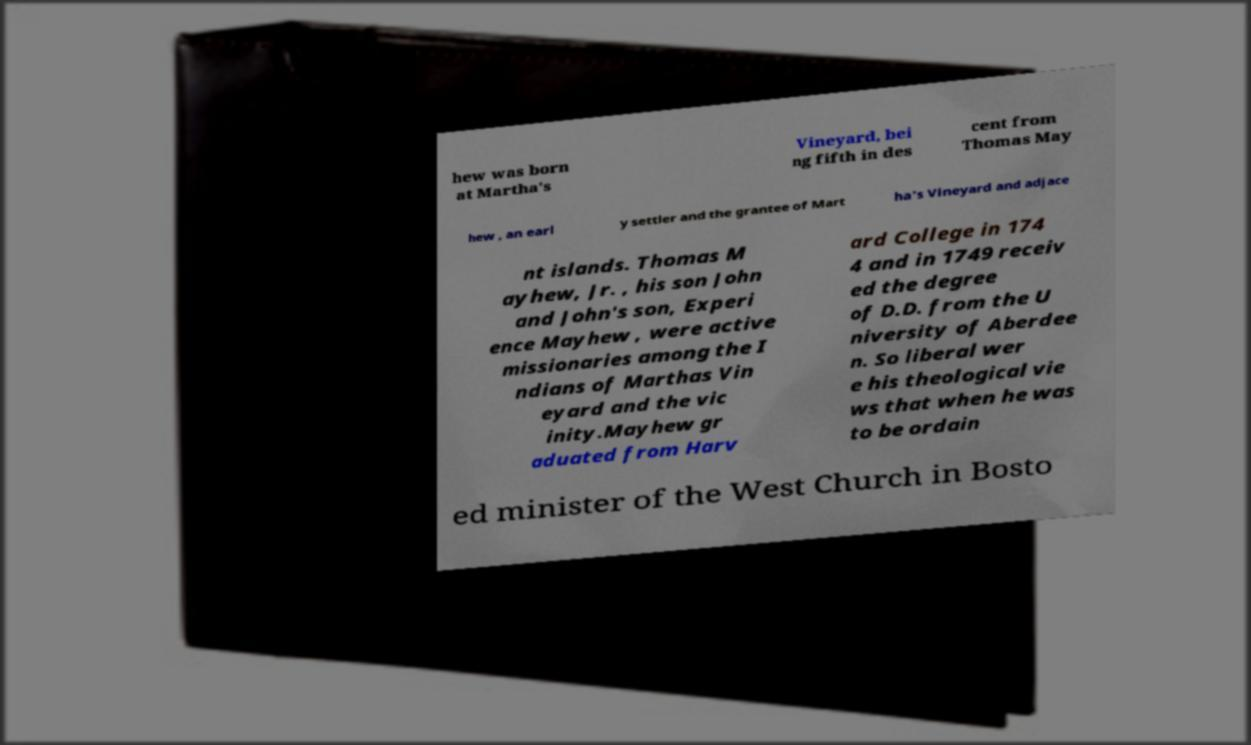What messages or text are displayed in this image? I need them in a readable, typed format. hew was born at Martha's Vineyard, bei ng fifth in des cent from Thomas May hew , an earl y settler and the grantee of Mart ha's Vineyard and adjace nt islands. Thomas M ayhew, Jr. , his son John and John's son, Experi ence Mayhew , were active missionaries among the I ndians of Marthas Vin eyard and the vic inity.Mayhew gr aduated from Harv ard College in 174 4 and in 1749 receiv ed the degree of D.D. from the U niversity of Aberdee n. So liberal wer e his theological vie ws that when he was to be ordain ed minister of the West Church in Bosto 